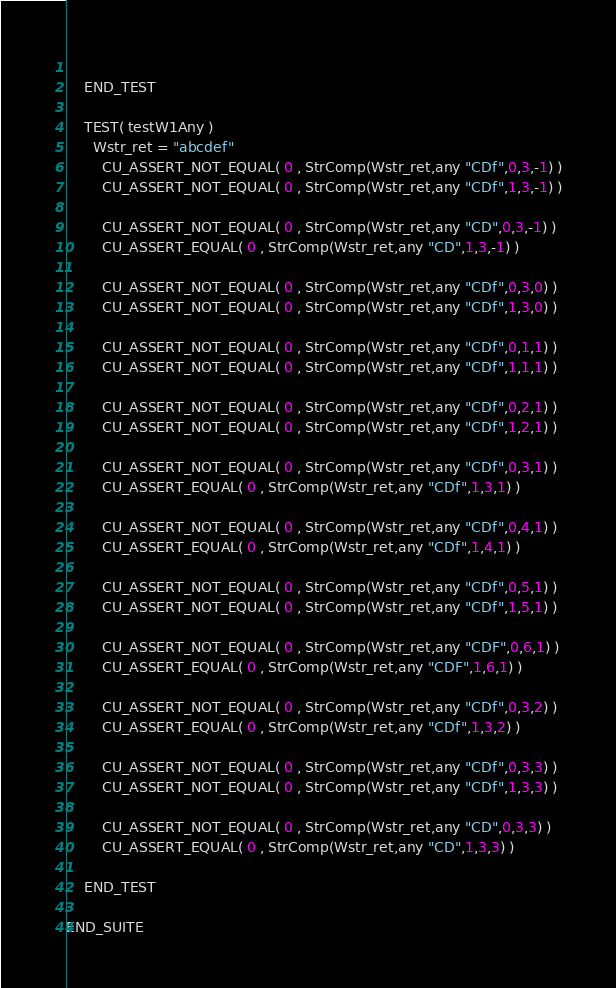Convert code to text. <code><loc_0><loc_0><loc_500><loc_500><_VisualBasic_>		
	END_TEST

	TEST( testW1Any )
      Wstr_ret = "abcdef"
		CU_ASSERT_NOT_EQUAL( 0 , StrComp(Wstr_ret,any "CDf",0,3,-1) )
		CU_ASSERT_NOT_EQUAL( 0 , StrComp(Wstr_ret,any "CDf",1,3,-1) )
		
		CU_ASSERT_NOT_EQUAL( 0 , StrComp(Wstr_ret,any "CD",0,3,-1) )
		CU_ASSERT_EQUAL( 0 , StrComp(Wstr_ret,any "CD",1,3,-1) )
		
		CU_ASSERT_NOT_EQUAL( 0 , StrComp(Wstr_ret,any "CDf",0,3,0) )
		CU_ASSERT_NOT_EQUAL( 0 , StrComp(Wstr_ret,any "CDf",1,3,0) )
		
		CU_ASSERT_NOT_EQUAL( 0 , StrComp(Wstr_ret,any "CDf",0,1,1) )
		CU_ASSERT_NOT_EQUAL( 0 , StrComp(Wstr_ret,any "CDf",1,1,1) )
		
		CU_ASSERT_NOT_EQUAL( 0 , StrComp(Wstr_ret,any "CDf",0,2,1) )
		CU_ASSERT_NOT_EQUAL( 0 , StrComp(Wstr_ret,any "CDf",1,2,1) )
		
		CU_ASSERT_NOT_EQUAL( 0 , StrComp(Wstr_ret,any "CDf",0,3,1) )
		CU_ASSERT_EQUAL( 0 , StrComp(Wstr_ret,any "CDf",1,3,1) )
		
		CU_ASSERT_NOT_EQUAL( 0 , StrComp(Wstr_ret,any "CDf",0,4,1) )
		CU_ASSERT_EQUAL( 0 , StrComp(Wstr_ret,any "CDf",1,4,1) )
		
		CU_ASSERT_NOT_EQUAL( 0 , StrComp(Wstr_ret,any "CDf",0,5,1) )
		CU_ASSERT_NOT_EQUAL( 0 , StrComp(Wstr_ret,any "CDf",1,5,1) )
		
		CU_ASSERT_NOT_EQUAL( 0 , StrComp(Wstr_ret,any "CDF",0,6,1) )
		CU_ASSERT_EQUAL( 0 , StrComp(Wstr_ret,any "CDF",1,6,1) )
		
		CU_ASSERT_NOT_EQUAL( 0 , StrComp(Wstr_ret,any "CDf",0,3,2) )
		CU_ASSERT_EQUAL( 0 , StrComp(Wstr_ret,any "CDf",1,3,2) )
		
		CU_ASSERT_NOT_EQUAL( 0 , StrComp(Wstr_ret,any "CDf",0,3,3) )
		CU_ASSERT_NOT_EQUAL( 0 , StrComp(Wstr_ret,any "CDf",1,3,3) )
		
		CU_ASSERT_NOT_EQUAL( 0 , StrComp(Wstr_ret,any "CD",0,3,3) )
		CU_ASSERT_EQUAL( 0 , StrComp(Wstr_ret,any "CD",1,3,3) )
		
	END_TEST
		
END_SUITE
</code> 